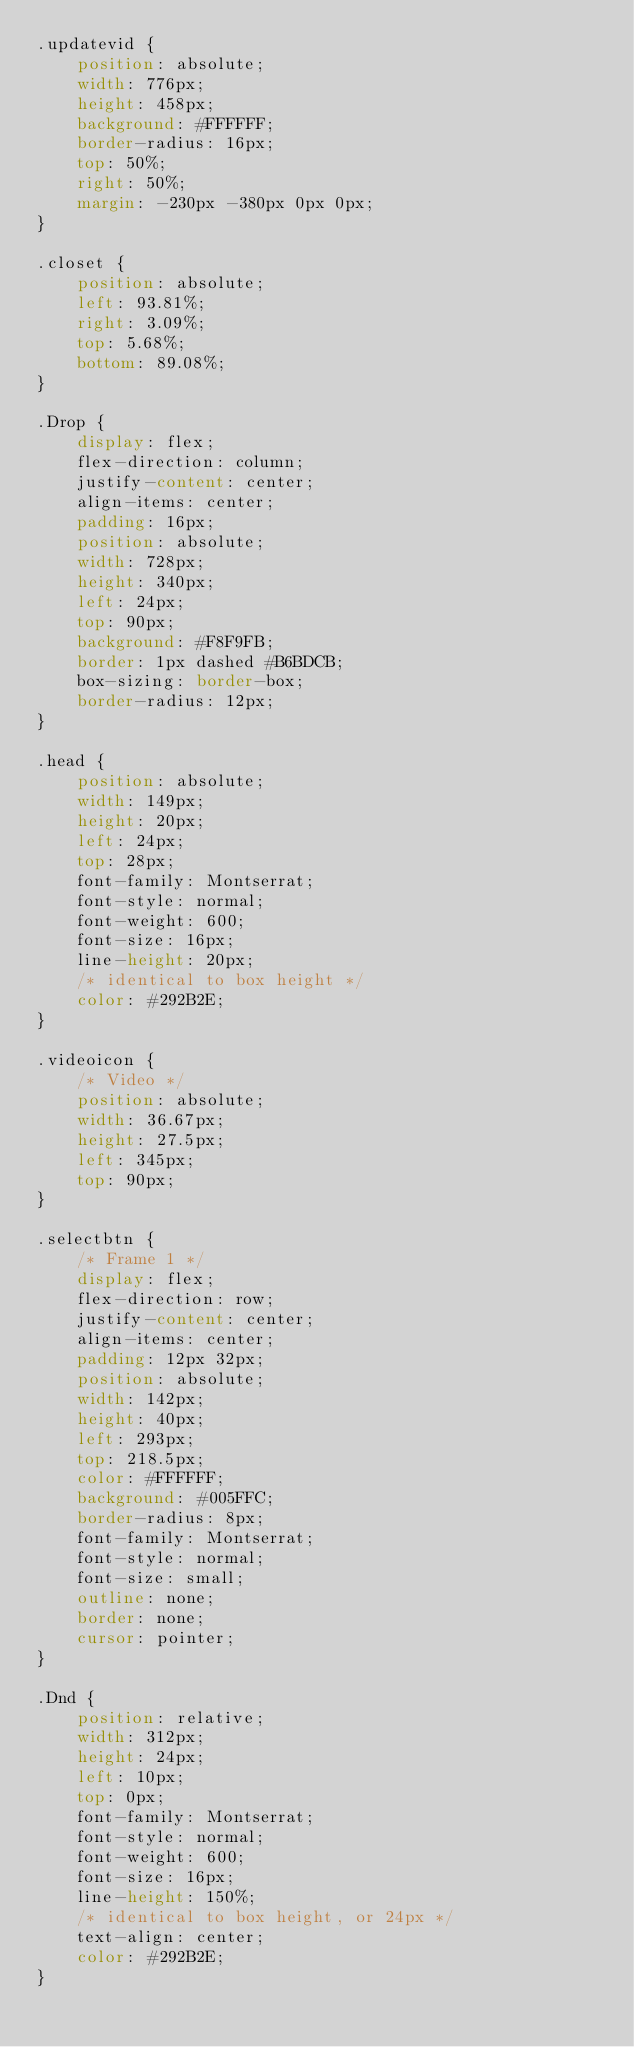Convert code to text. <code><loc_0><loc_0><loc_500><loc_500><_CSS_>.updatevid {
    position: absolute;
    width: 776px;
    height: 458px;
    background: #FFFFFF;
    border-radius: 16px;
    top: 50%;
    right: 50%;
    margin: -230px -380px 0px 0px;
}

.closet {
    position: absolute;
    left: 93.81%;
    right: 3.09%;
    top: 5.68%;
    bottom: 89.08%;
}

.Drop {
    display: flex;
    flex-direction: column;
    justify-content: center;
    align-items: center;
    padding: 16px;
    position: absolute;
    width: 728px;
    height: 340px;
    left: 24px;
    top: 90px;
    background: #F8F9FB;
    border: 1px dashed #B6BDCB;
    box-sizing: border-box;
    border-radius: 12px;
}

.head {
    position: absolute;
    width: 149px;
    height: 20px;
    left: 24px;
    top: 28px;
    font-family: Montserrat;
    font-style: normal;
    font-weight: 600;
    font-size: 16px;
    line-height: 20px;
    /* identical to box height */
    color: #292B2E;
}

.videoicon {
    /* Video */
    position: absolute;
    width: 36.67px;
    height: 27.5px;
    left: 345px;
    top: 90px;
}

.selectbtn {
    /* Frame 1 */
    display: flex;
    flex-direction: row;
    justify-content: center;
    align-items: center;
    padding: 12px 32px;
    position: absolute;
    width: 142px;
    height: 40px;
    left: 293px;
    top: 218.5px;
    color: #FFFFFF;
    background: #005FFC;
    border-radius: 8px;
    font-family: Montserrat;
    font-style: normal;
    font-size: small;
    outline: none;
    border: none;
    cursor: pointer;
}

.Dnd {
    position: relative;
    width: 312px;
    height: 24px;
    left: 10px;
    top: 0px;
    font-family: Montserrat;
    font-style: normal;
    font-weight: 600;
    font-size: 16px;
    line-height: 150%;
    /* identical to box height, or 24px */
    text-align: center;
    color: #292B2E;
}</code> 